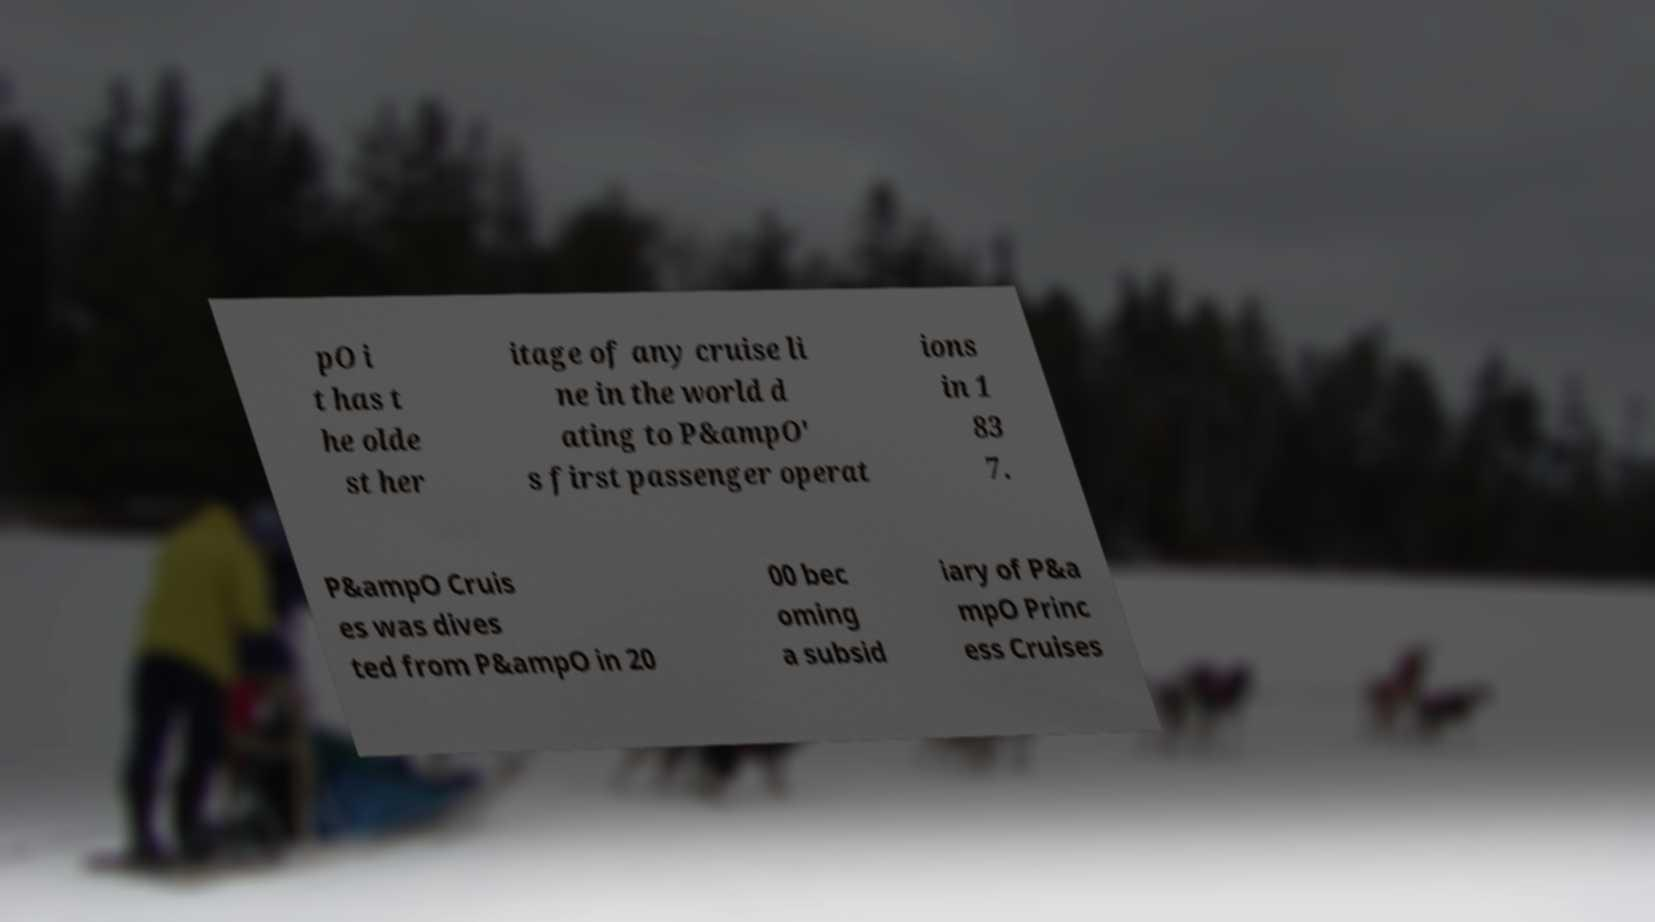There's text embedded in this image that I need extracted. Can you transcribe it verbatim? pO i t has t he olde st her itage of any cruise li ne in the world d ating to P&ampO' s first passenger operat ions in 1 83 7. P&ampO Cruis es was dives ted from P&ampO in 20 00 bec oming a subsid iary of P&a mpO Princ ess Cruises 